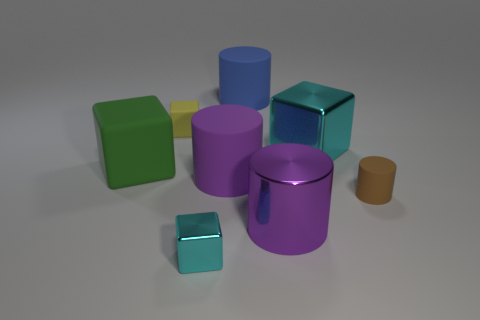Subtract 1 cylinders. How many cylinders are left? 3 Subtract all cyan cylinders. Subtract all blue spheres. How many cylinders are left? 4 Add 1 big brown rubber cylinders. How many objects exist? 9 Add 7 large cyan cubes. How many large cyan cubes exist? 8 Subtract 2 purple cylinders. How many objects are left? 6 Subtract all yellow matte things. Subtract all small green rubber cylinders. How many objects are left? 7 Add 1 green cubes. How many green cubes are left? 2 